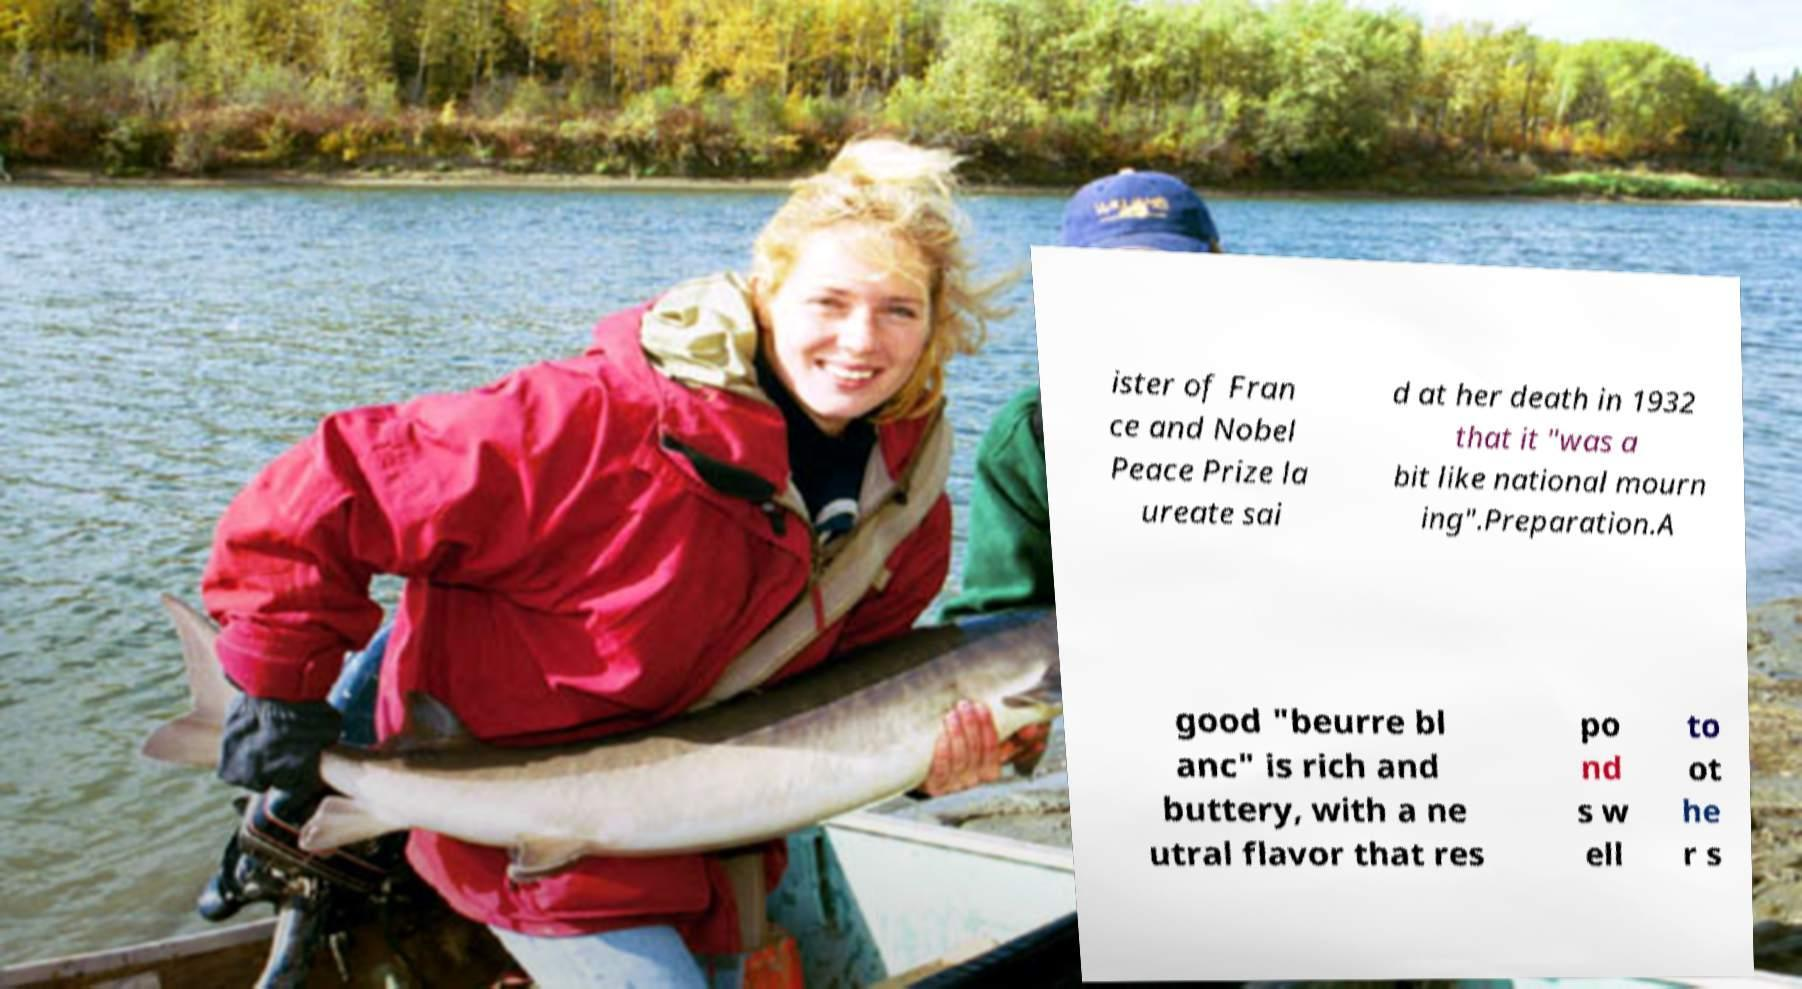Could you extract and type out the text from this image? ister of Fran ce and Nobel Peace Prize la ureate sai d at her death in 1932 that it "was a bit like national mourn ing".Preparation.A good "beurre bl anc" is rich and buttery, with a ne utral flavor that res po nd s w ell to ot he r s 